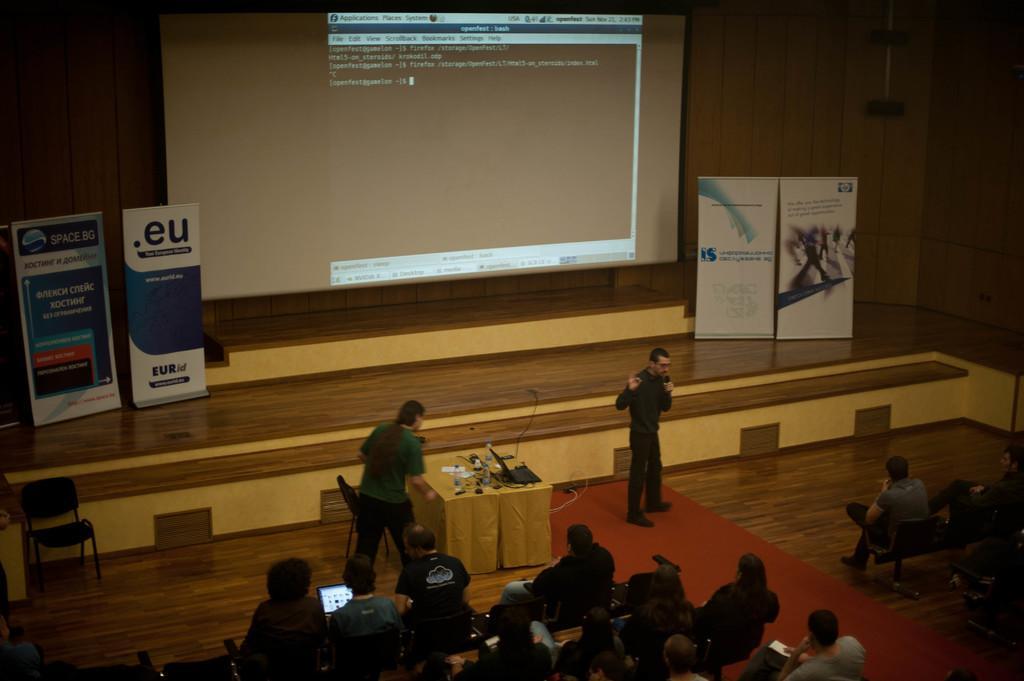Can you describe this image briefly? In this image we can see a group of people. There is a projector screen in the image. A man speaking into a microphone. There is a stage and few advertising boards on it. There is a chair in the image. There are objects placed on the table. 